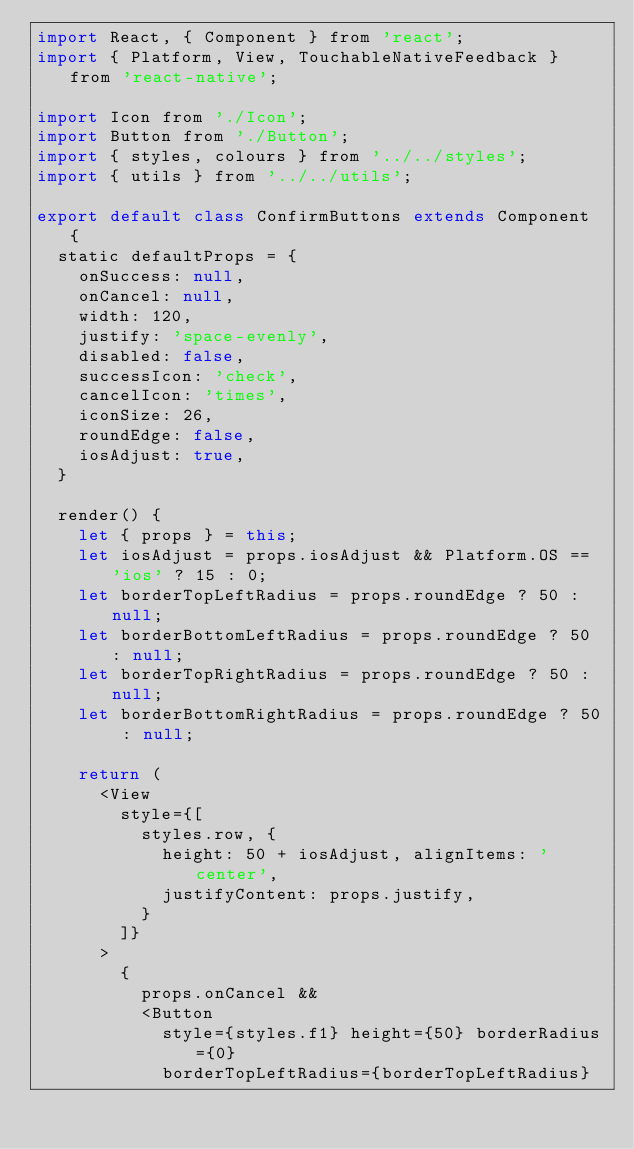Convert code to text. <code><loc_0><loc_0><loc_500><loc_500><_JavaScript_>import React, { Component } from 'react';
import { Platform, View, TouchableNativeFeedback } from 'react-native';

import Icon from './Icon';
import Button from './Button';
import { styles, colours } from '../../styles';
import { utils } from '../../utils';

export default class ConfirmButtons extends Component {
  static defaultProps = {
    onSuccess: null,
    onCancel: null,
    width: 120,
    justify: 'space-evenly',
    disabled: false,
    successIcon: 'check',
    cancelIcon: 'times',
    iconSize: 26,
    roundEdge: false,
    iosAdjust: true,
  }

  render() {
    let { props } = this;
    let iosAdjust = props.iosAdjust && Platform.OS == 'ios' ? 15 : 0;
    let borderTopLeftRadius = props.roundEdge ? 50 : null;
    let borderBottomLeftRadius = props.roundEdge ? 50 : null;
    let borderTopRightRadius = props.roundEdge ? 50 : null;
    let borderBottomRightRadius = props.roundEdge ? 50 : null;

    return (
      <View 
        style={[
          styles.row, {
            height: 50 + iosAdjust, alignItems: 'center',
            justifyContent: props.justify,
          }
        ]}
      >
        {
          props.onCancel &&
          <Button
            style={styles.f1} height={50} borderRadius={0}
            borderTopLeftRadius={borderTopLeftRadius}</code> 